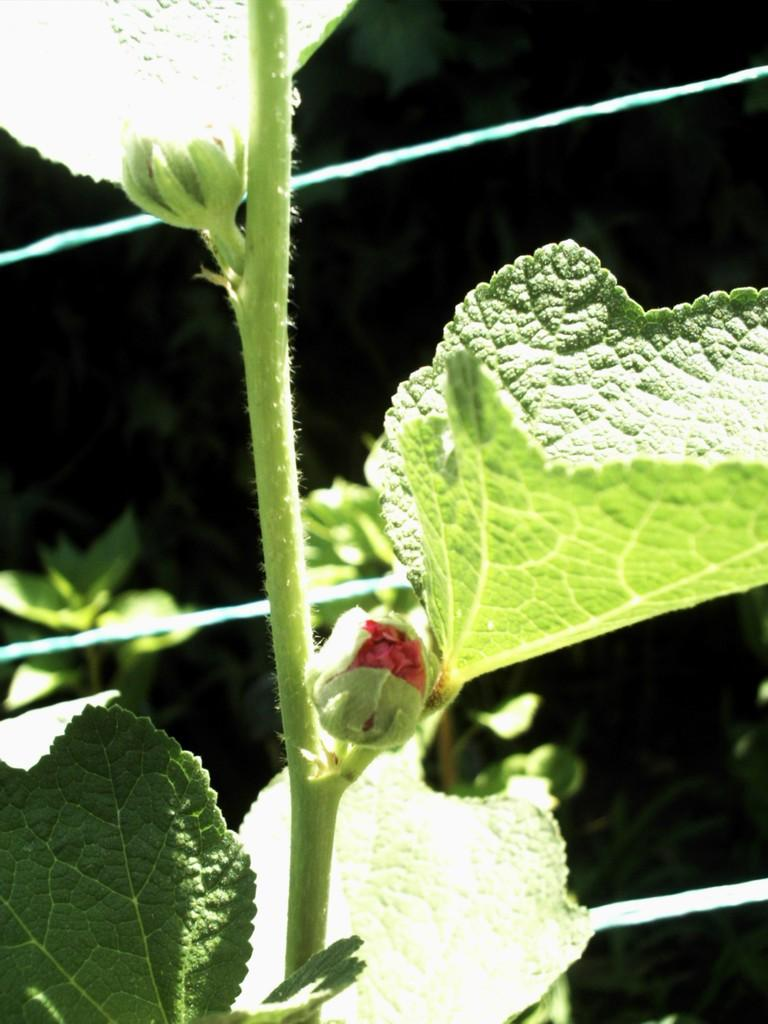What type of plant parts can be seen in the image? There are flower buds and leaves in the image. What is the main subject of the image? There is a plant in the image. What is the color of the background in the image? The background of the image is dark. What else can be seen in the image besides the plant? There are wires visible in the image. Reasoning: Let'g: Let's think step by step in order to produce the conversation. We start by identifying the main subject of the image, which is the plant. Then, we describe the specific parts of the plant that are visible, such as the flower buds and leaves. Next, we mention the background color, which is dark. Finally, we acknowledge the presence of other objects in the image, such as the wires. Absurd Question/Answer: Can you tell me what color the orange is in the image? There is no orange present in the image. What type of cap is being worn by the plant in the image? There is no cap present in the image; it is a plant with flower buds and leaves. 